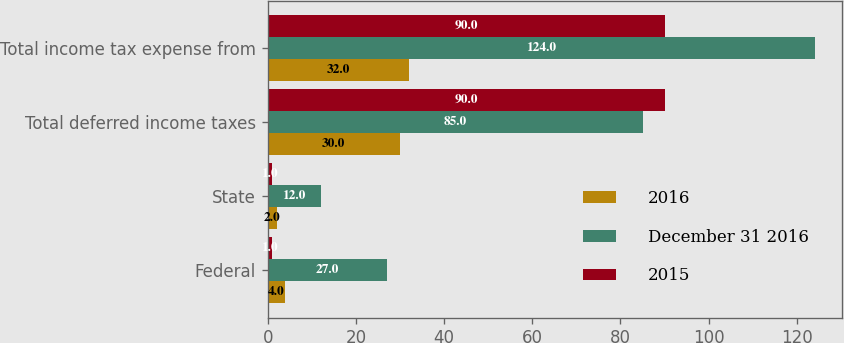Convert chart. <chart><loc_0><loc_0><loc_500><loc_500><stacked_bar_chart><ecel><fcel>Federal<fcel>State<fcel>Total deferred income taxes<fcel>Total income tax expense from<nl><fcel>2016<fcel>4<fcel>2<fcel>30<fcel>32<nl><fcel>December 31 2016<fcel>27<fcel>12<fcel>85<fcel>124<nl><fcel>2015<fcel>1<fcel>1<fcel>90<fcel>90<nl></chart> 